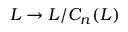Convert formula to latex. <formula><loc_0><loc_0><loc_500><loc_500>L \to L / C _ { n } ( L )</formula> 